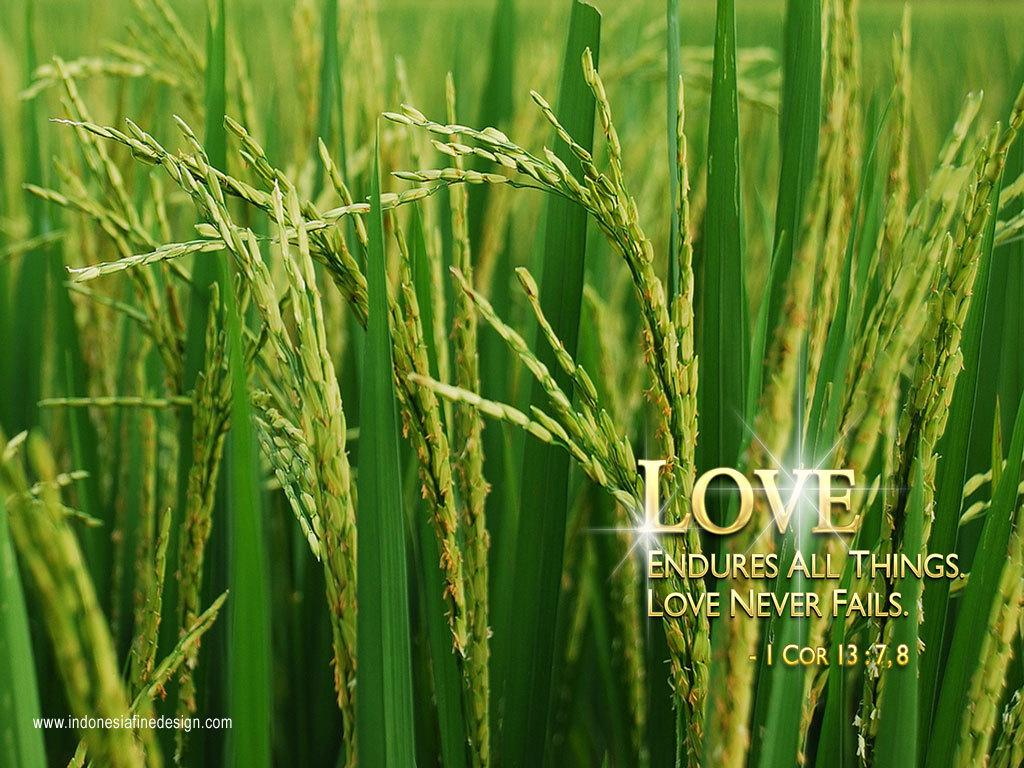What type of vegetation can be seen in the image? There are crops in the image. Is there any text present in the image? Yes, there is some text on the right side of the image. What type of animals can be seen in the zoo in the image? There is no zoo present in the image; it features crops and text. How many squares are visible in the image? There is no square present in the image. 